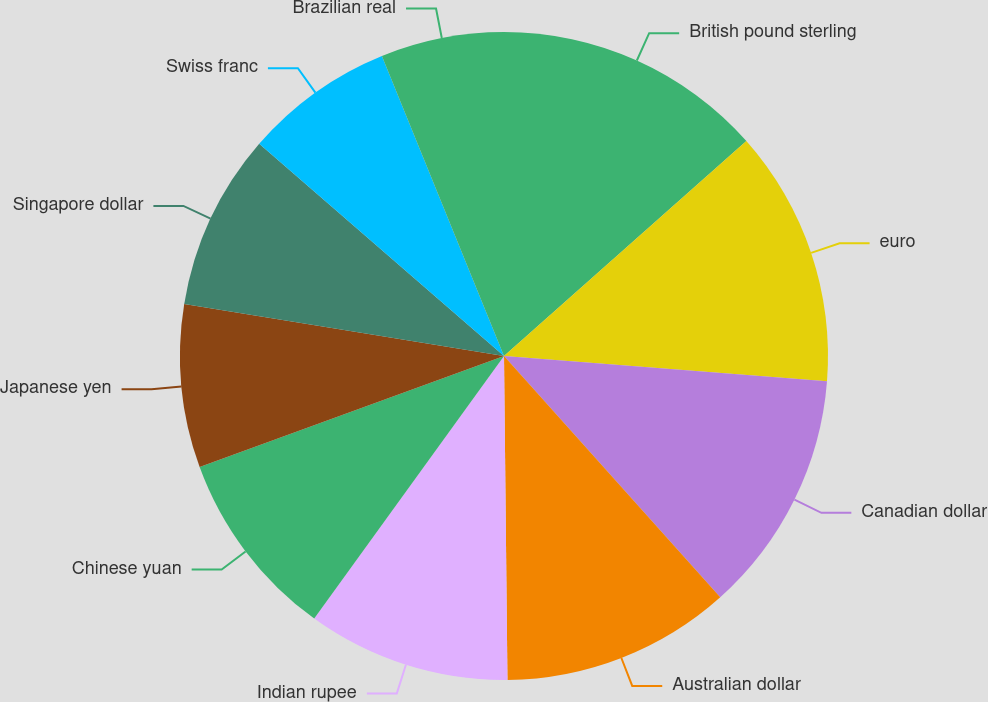Convert chart. <chart><loc_0><loc_0><loc_500><loc_500><pie_chart><fcel>British pound sterling<fcel>euro<fcel>Canadian dollar<fcel>Australian dollar<fcel>Indian rupee<fcel>Chinese yuan<fcel>Japanese yen<fcel>Singapore dollar<fcel>Swiss franc<fcel>Brazilian real<nl><fcel>13.45%<fcel>12.79%<fcel>12.13%<fcel>11.46%<fcel>10.13%<fcel>9.47%<fcel>8.14%<fcel>8.8%<fcel>7.48%<fcel>6.15%<nl></chart> 